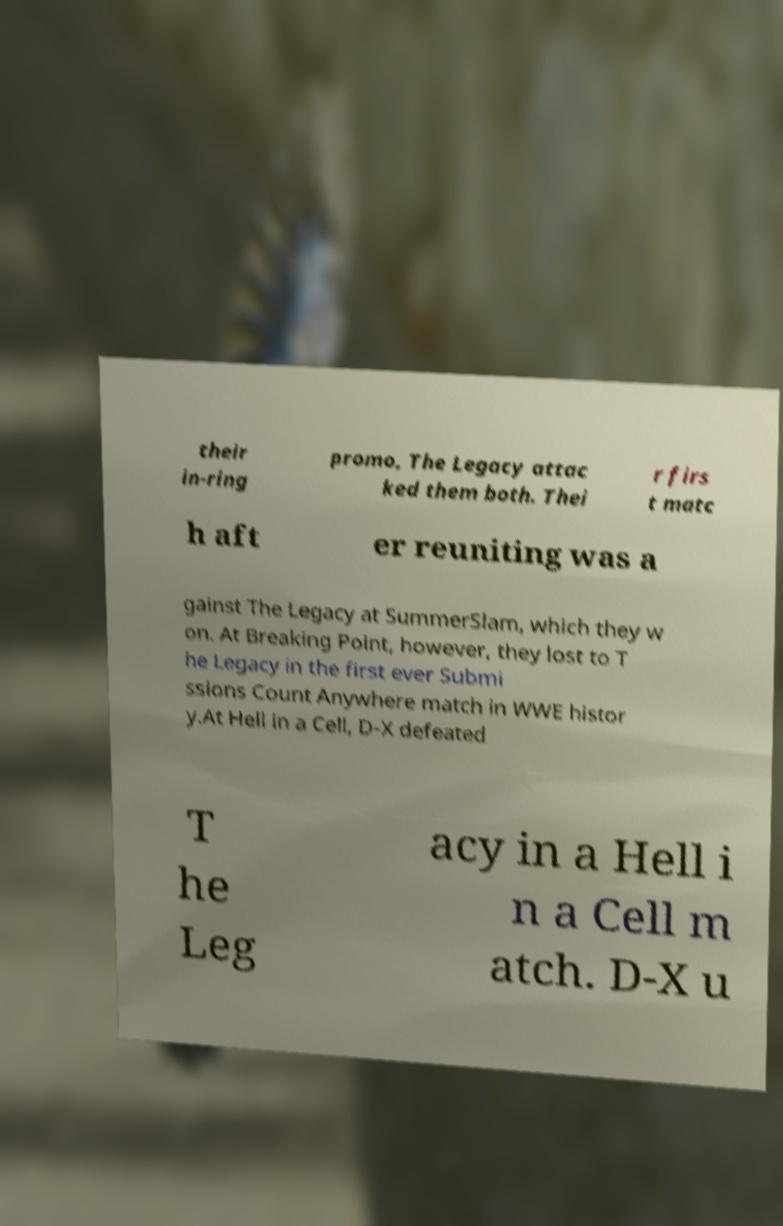Please read and relay the text visible in this image. What does it say? their in-ring promo, The Legacy attac ked them both. Thei r firs t matc h aft er reuniting was a gainst The Legacy at SummerSlam, which they w on. At Breaking Point, however, they lost to T he Legacy in the first ever Submi ssions Count Anywhere match in WWE histor y.At Hell in a Cell, D-X defeated T he Leg acy in a Hell i n a Cell m atch. D-X u 